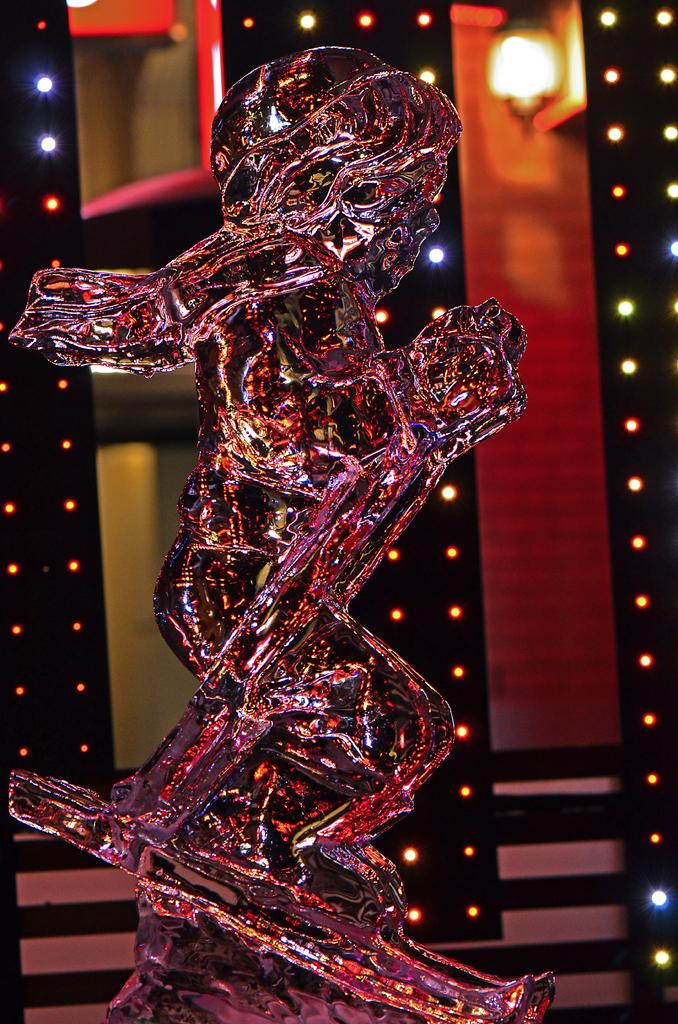What is the main subject in the image? There is a statue in the image. What else can be seen in the background of the image? There are lights visible in the background of the image. What type of army is present near the statue in the image? There is no army present near the statue in the image. What type of salt can be seen on the statue in the image? There is no salt present on the statue in the image. 